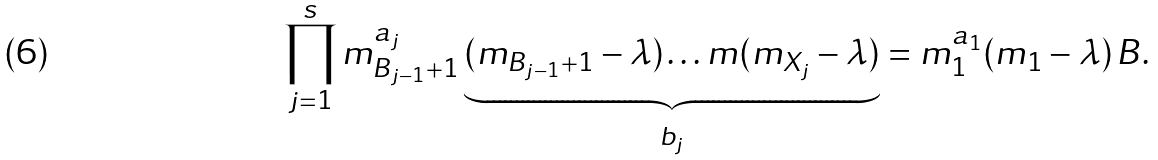<formula> <loc_0><loc_0><loc_500><loc_500>\prod _ { j = 1 } ^ { s } m _ { B _ { j - 1 } + 1 } ^ { a _ { j } } \underbrace { ( m _ { B _ { j - 1 } + 1 } - \lambda ) \dots m ( m _ { X _ { j } } - \lambda ) } _ { b _ { j } } = m _ { 1 } ^ { a _ { 1 } } ( m _ { 1 } - \lambda ) \, B .</formula> 